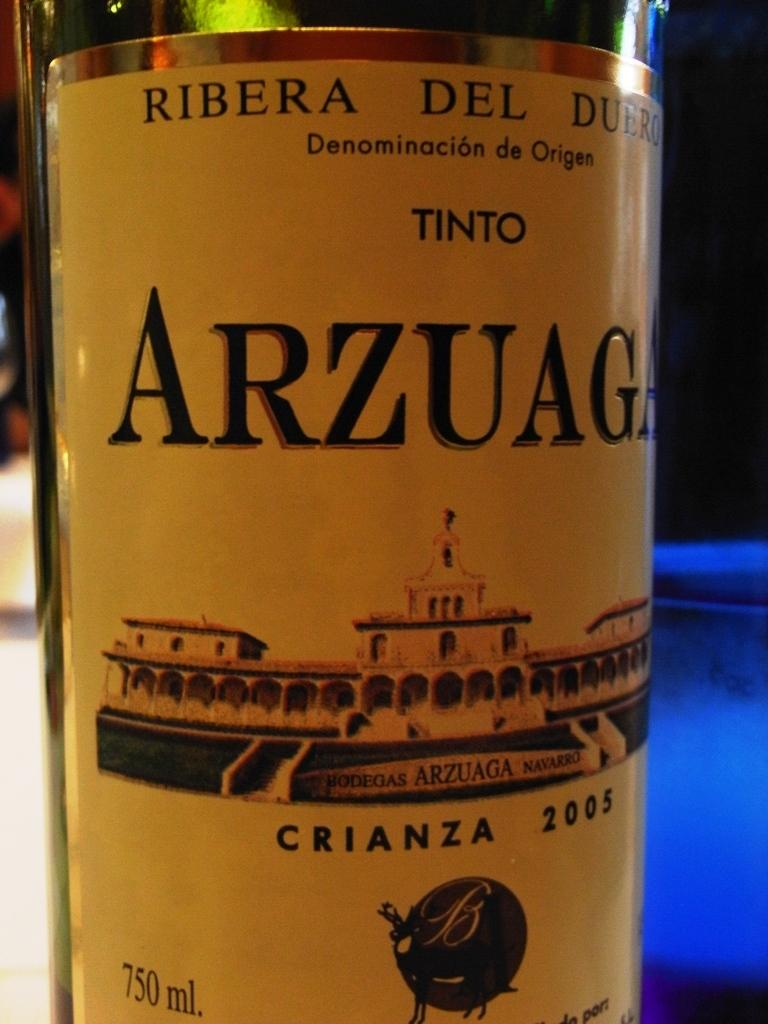<image>
Render a clear and concise summary of the photo. A bottle of Arzuaga from 2005 has a picture of a building on the label. 